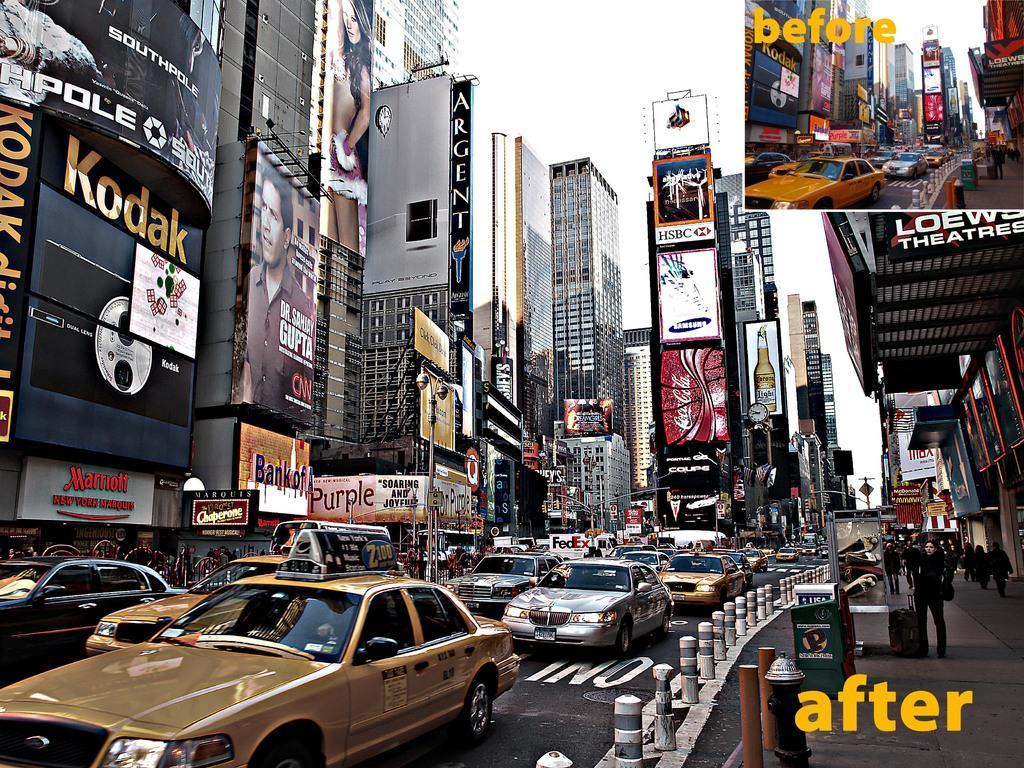In one or two sentences, can you explain what this image depicts? In the foreground, I can see a fence, boxes, crowd, fleets of vehicles, sign boards and shops on the road. In the background, I can see buildings, towers, hoardings, posters and the sky. This image is taken, maybe on the road. 